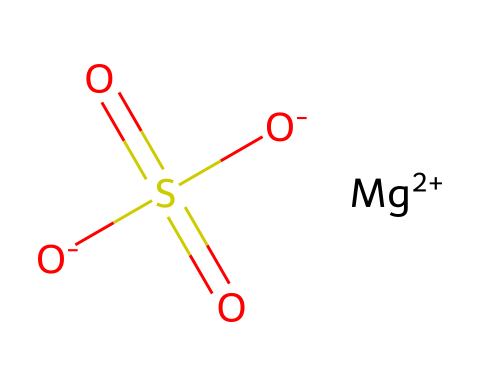How many sulfur atoms are present in magnesium sulfate? The chemical structure indicates one sulfur atom is present, which is shown as S in the SMILES representation.
Answer: 1 What is the charge of the magnesium ion in this compound? The chemical has a [Mg+2] representation, indicating that the magnesium ion carries a +2 charge.
Answer: +2 How many oxygen atoms are involved in the sulfate group? The sulfate group structure shows that there are four oxygen atoms connected to the sulfur atom, which accounts for the -O and the three =O double bonds.
Answer: 4 What is the main application of magnesium sulfate in medicinal use? Magnesium sulfate is commonly known as Epsom salt, which is typically used for muscle recovery and relaxation.
Answer: muscle recovery What type of electrolyte is magnesium sulfate considered? Magnesium sulfate dissociates into ions in solution, making it a type of ionic electrolyte that can conduct electricity when dissolved in water.
Answer: ionic electrolyte How does magnesium sulfate benefit muscle recovery? Magnesium plays a role in muscle relaxation and reducing inflammation, making it beneficial for muscle recovery when absorbed through the skin or ingested.
Answer: reduces inflammation 